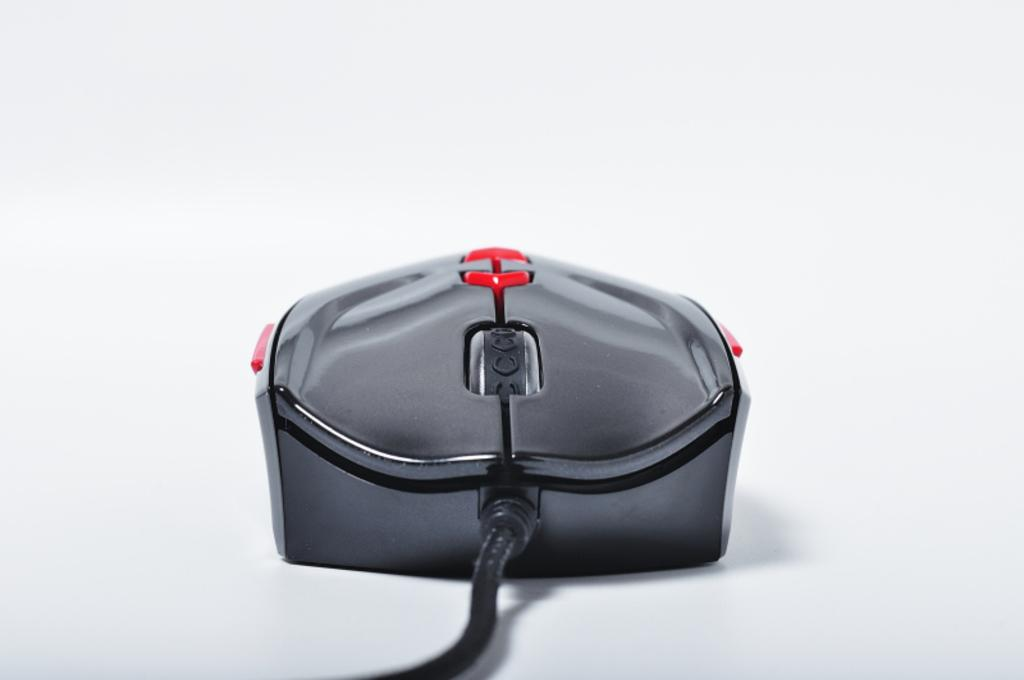What is the main subject of the image? There is a mouse in the image. What can be seen connected to the mouse? The mouse has a cable. What color is the background of the image? The background of the image is white. How many times does the mouse sneeze in the image? There is no indication of the mouse sneezing in the image, as it is an inanimate object. What type of selection is available on the top of the mouse? There is no mention of any selection or buttons on the top of the mouse in the provided facts. 